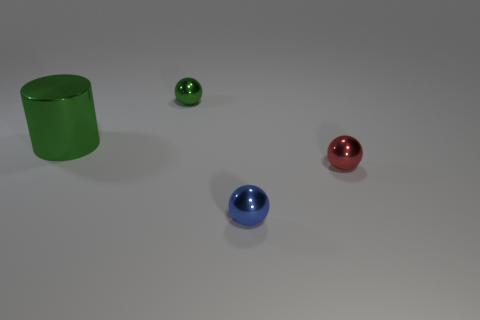Do the object that is in front of the tiny red metallic sphere and the object that is behind the cylinder have the same shape?
Keep it short and to the point. Yes. There is a red object; is its size the same as the object in front of the red object?
Your answer should be compact. Yes. How many other objects are there of the same material as the green cylinder?
Make the answer very short. 3. Are there any other things that are the same shape as the large thing?
Provide a succinct answer. No. The object that is to the left of the tiny metallic object that is behind the green metallic thing that is in front of the green ball is what color?
Your answer should be compact. Green. The small thing that is in front of the big green metal cylinder and behind the blue object has what shape?
Give a very brief answer. Sphere. Is there any other thing that is the same size as the cylinder?
Provide a succinct answer. No. There is a thing to the left of the small thing on the left side of the blue metallic ball; what is its color?
Your response must be concise. Green. There is a green metal object in front of the small thing that is behind the shiny thing on the right side of the tiny blue thing; what is its shape?
Your response must be concise. Cylinder. There is a thing that is both in front of the cylinder and behind the blue metal ball; how big is it?
Ensure brevity in your answer.  Small. 